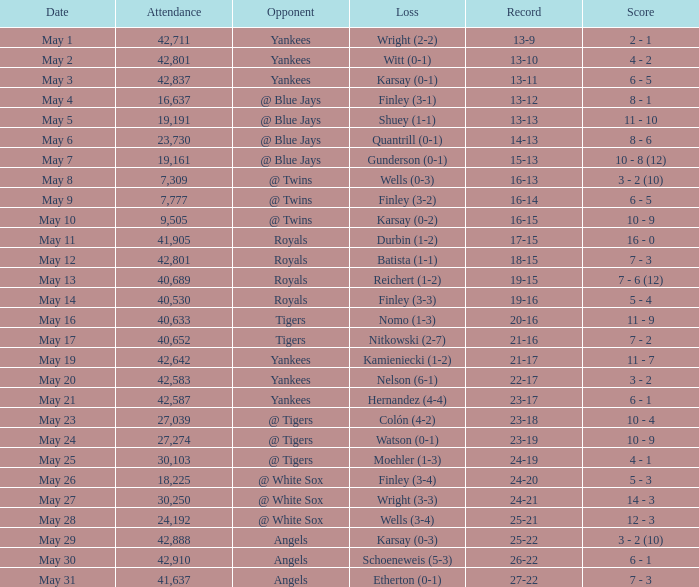What is the attendance for the game on May 25? 30103.0. 